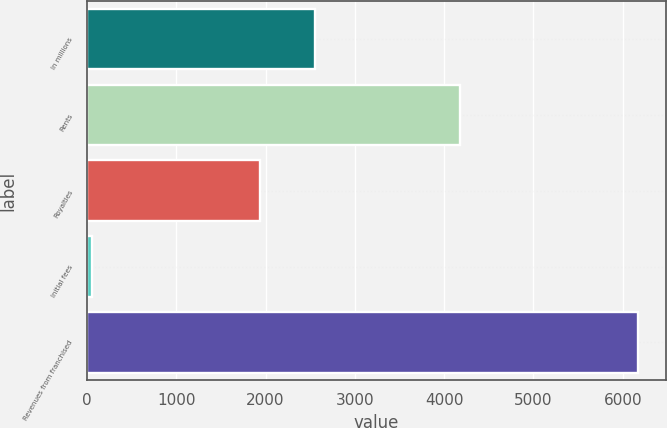Convert chart to OTSL. <chart><loc_0><loc_0><loc_500><loc_500><bar_chart><fcel>In millions<fcel>Rents<fcel>Royalties<fcel>Initial fees<fcel>Revenues from franchised<nl><fcel>2552.93<fcel>4177.2<fcel>1941.1<fcel>57.3<fcel>6175.6<nl></chart> 